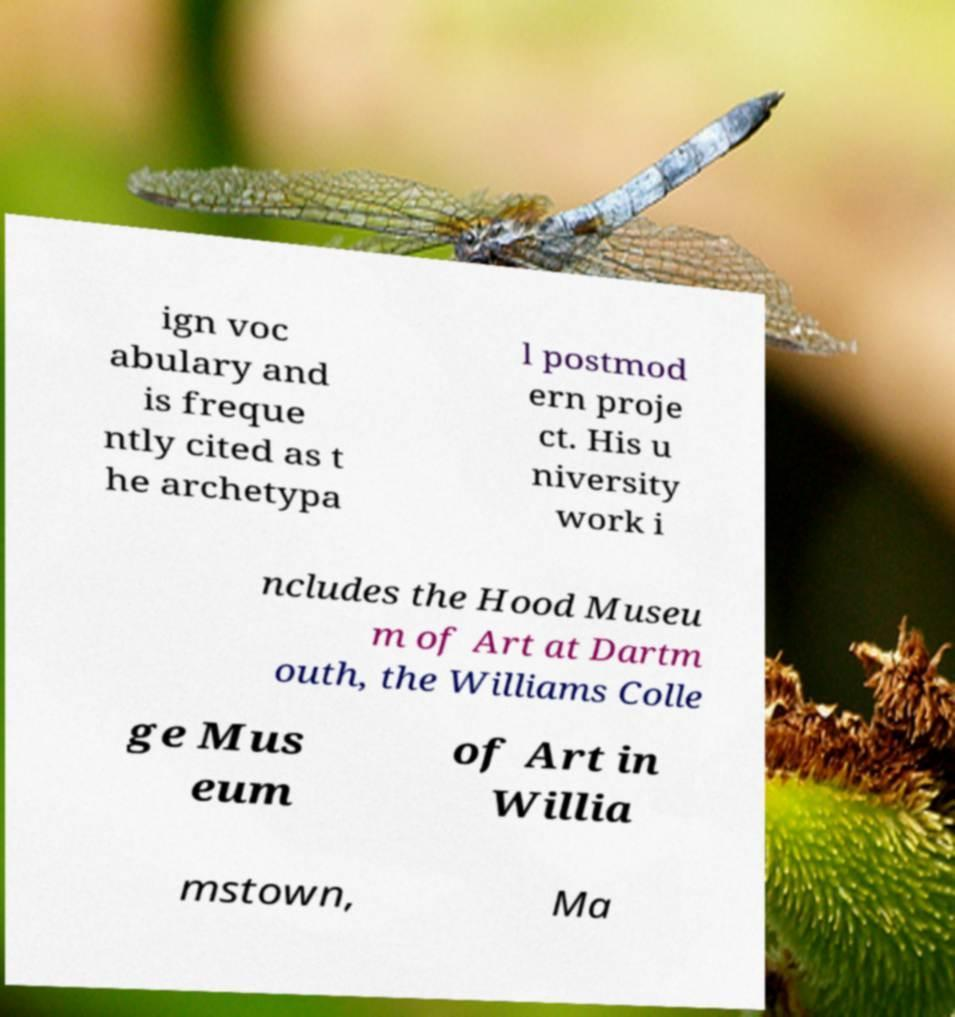Can you accurately transcribe the text from the provided image for me? ign voc abulary and is freque ntly cited as t he archetypa l postmod ern proje ct. His u niversity work i ncludes the Hood Museu m of Art at Dartm outh, the Williams Colle ge Mus eum of Art in Willia mstown, Ma 